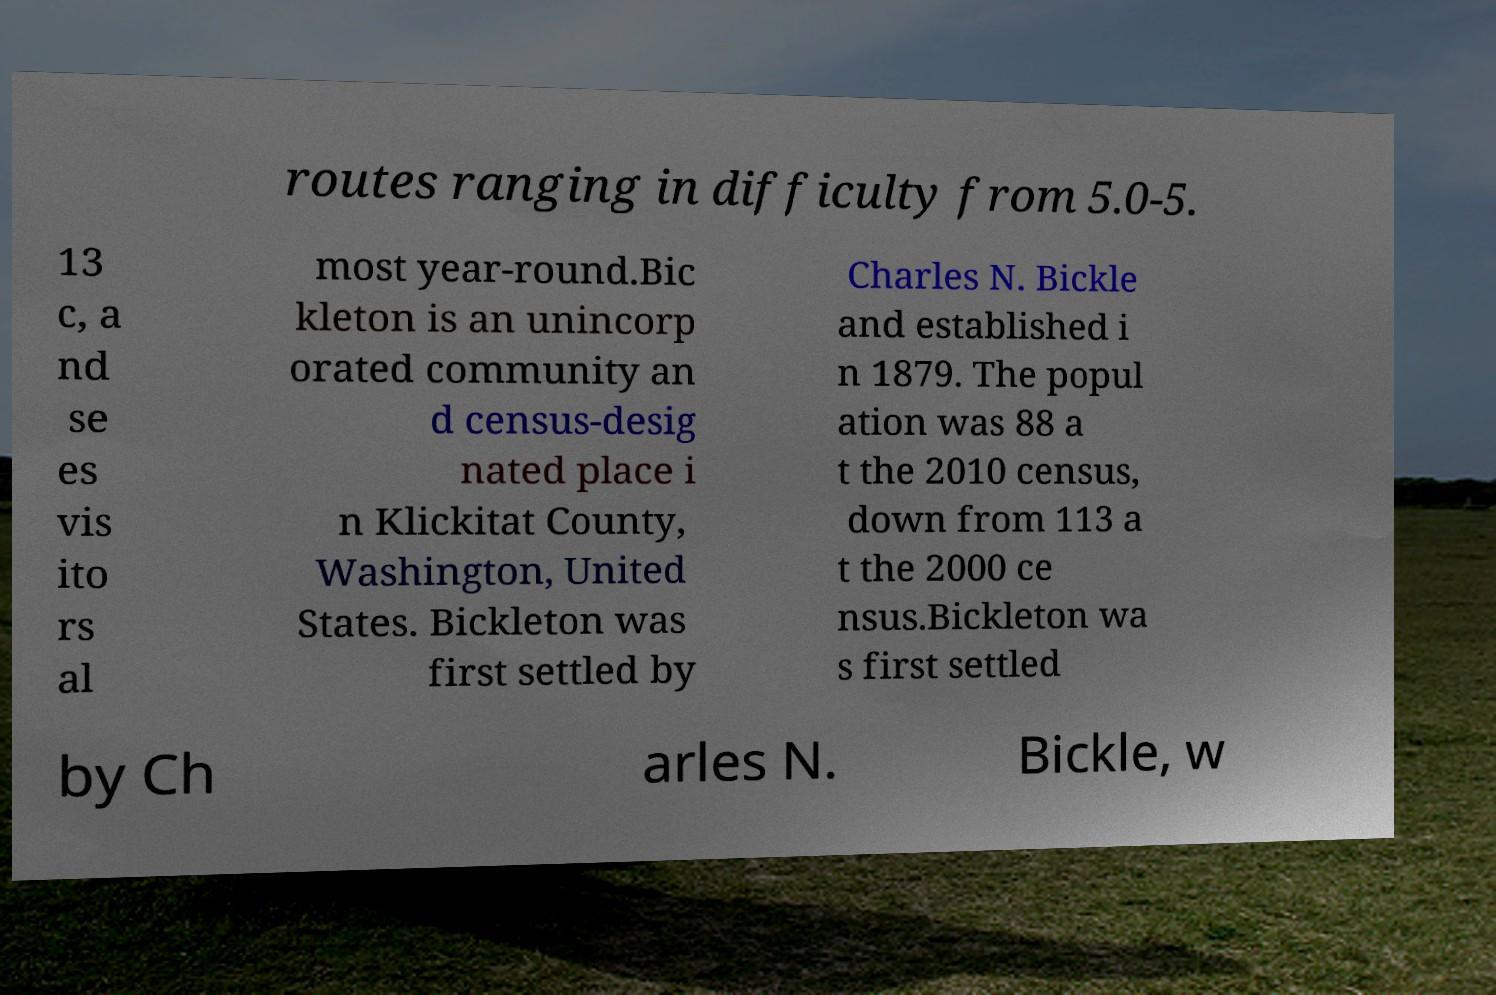Can you read and provide the text displayed in the image?This photo seems to have some interesting text. Can you extract and type it out for me? routes ranging in difficulty from 5.0-5. 13 c, a nd se es vis ito rs al most year-round.Bic kleton is an unincorp orated community an d census-desig nated place i n Klickitat County, Washington, United States. Bickleton was first settled by Charles N. Bickle and established i n 1879. The popul ation was 88 a t the 2010 census, down from 113 a t the 2000 ce nsus.Bickleton wa s first settled by Ch arles N. Bickle, w 